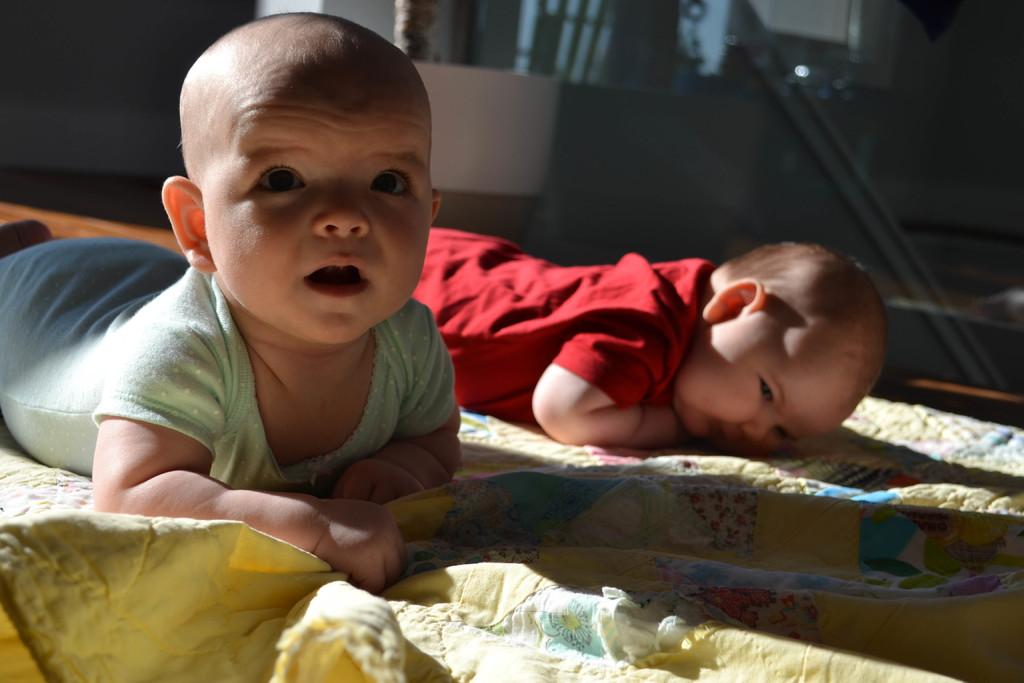What is the main subject of the image? The main subject of the image is babies. Where are the babies located in the image? The babies are lying on a bed. What type of division can be seen between the babies in the image? There is no division between the babies in the image; they are lying on a bed together. What kind of house is visible in the image? There is no house visible in the image; it only features babies lying on a bed. 